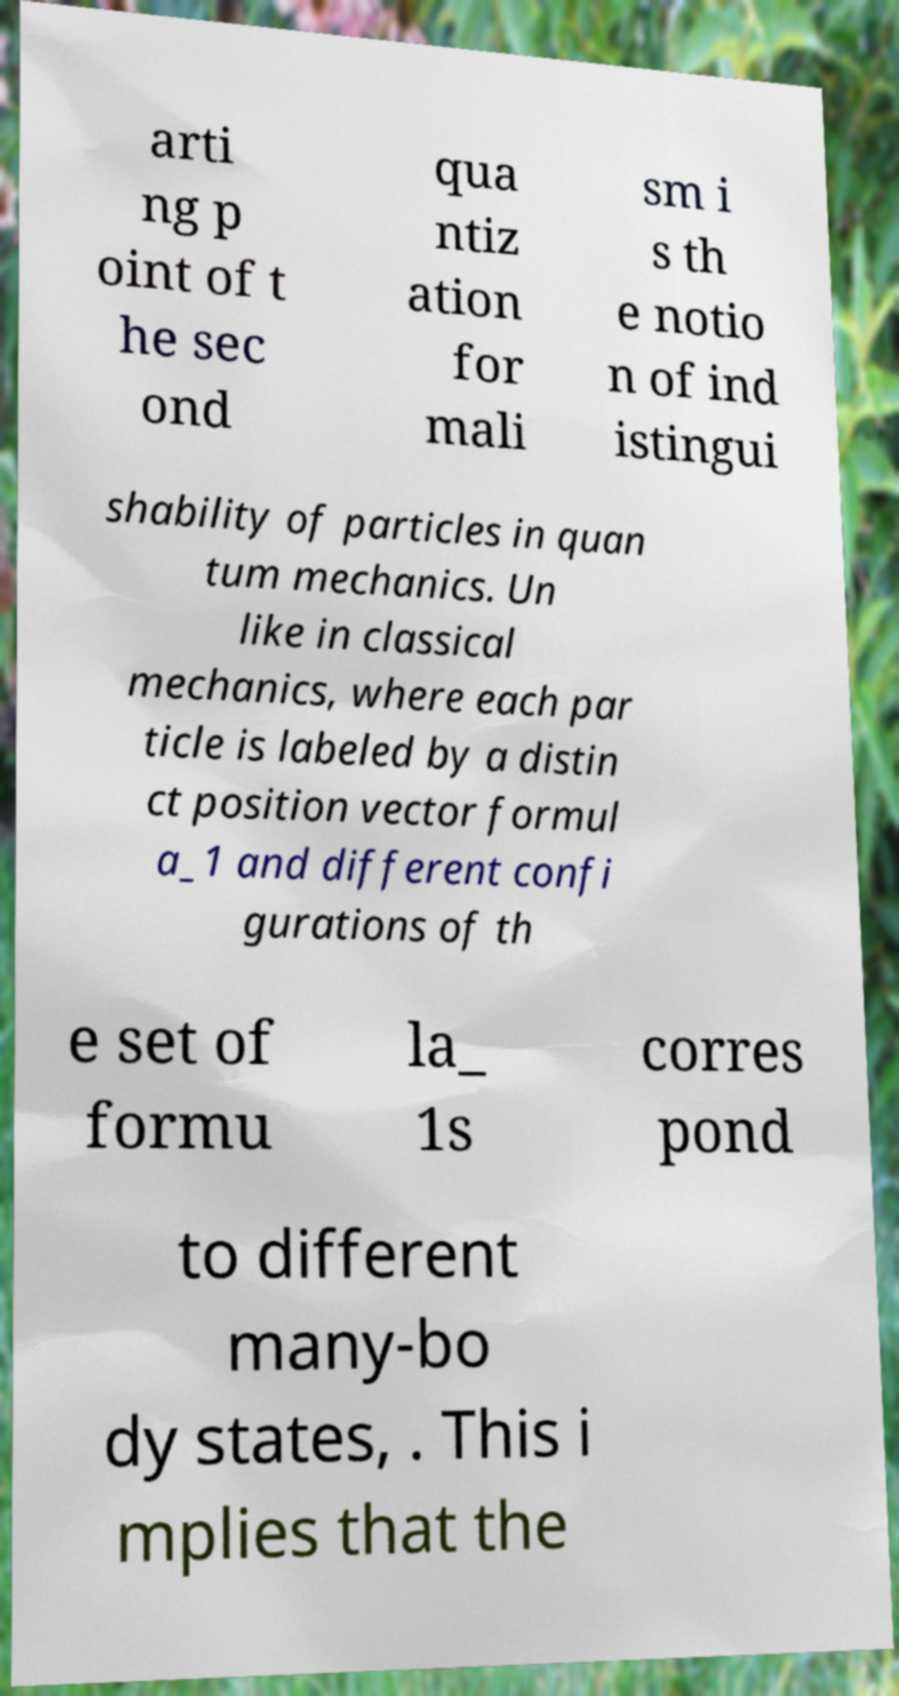There's text embedded in this image that I need extracted. Can you transcribe it verbatim? arti ng p oint of t he sec ond qua ntiz ation for mali sm i s th e notio n of ind istingui shability of particles in quan tum mechanics. Un like in classical mechanics, where each par ticle is labeled by a distin ct position vector formul a_1 and different confi gurations of th e set of formu la_ 1s corres pond to different many-bo dy states, . This i mplies that the 